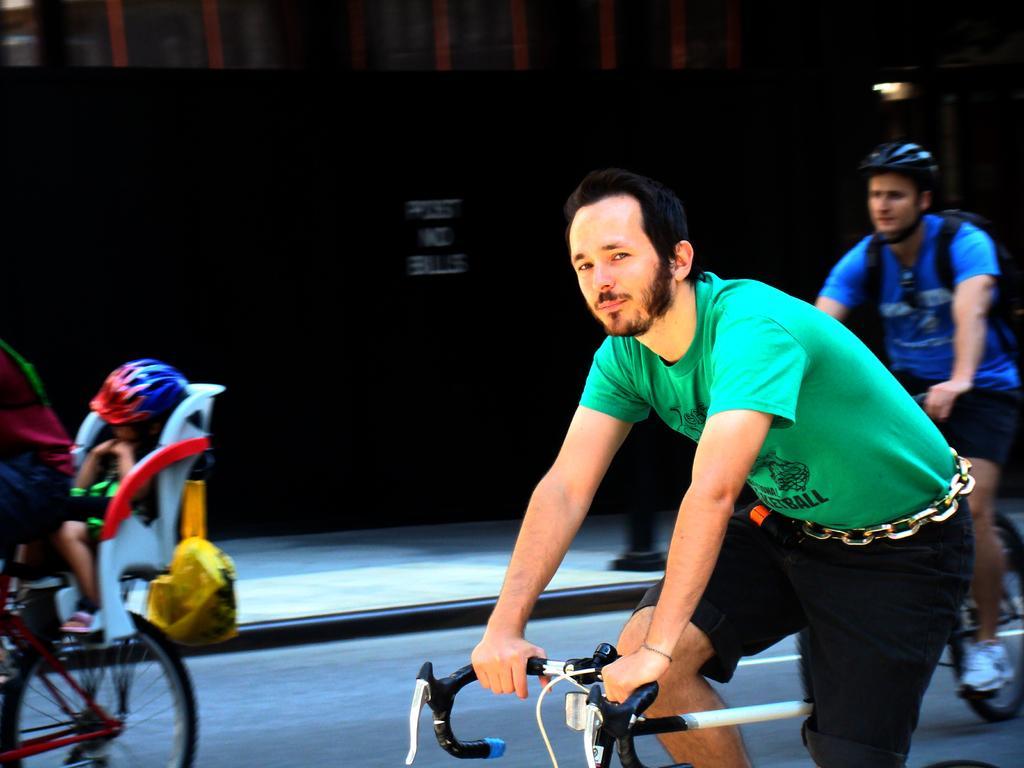How would you summarize this image in a sentence or two? It is a cycling race ,there are total three persons riding the cycle, in the background is black color board. 